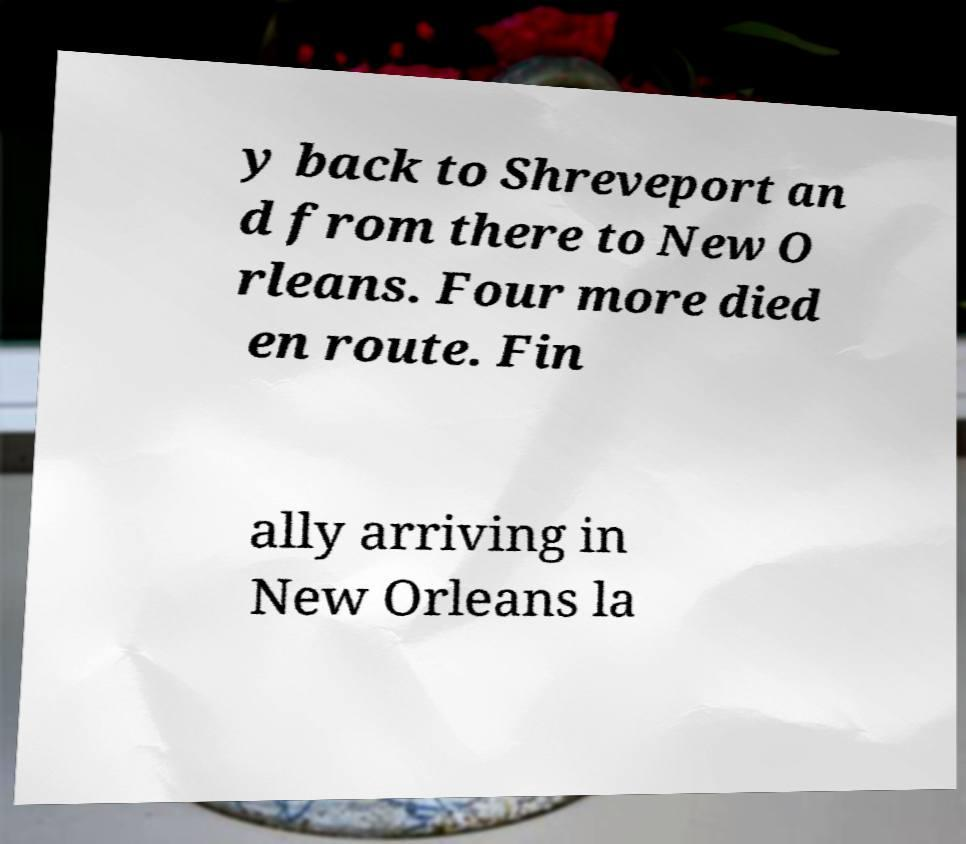What messages or text are displayed in this image? I need them in a readable, typed format. y back to Shreveport an d from there to New O rleans. Four more died en route. Fin ally arriving in New Orleans la 